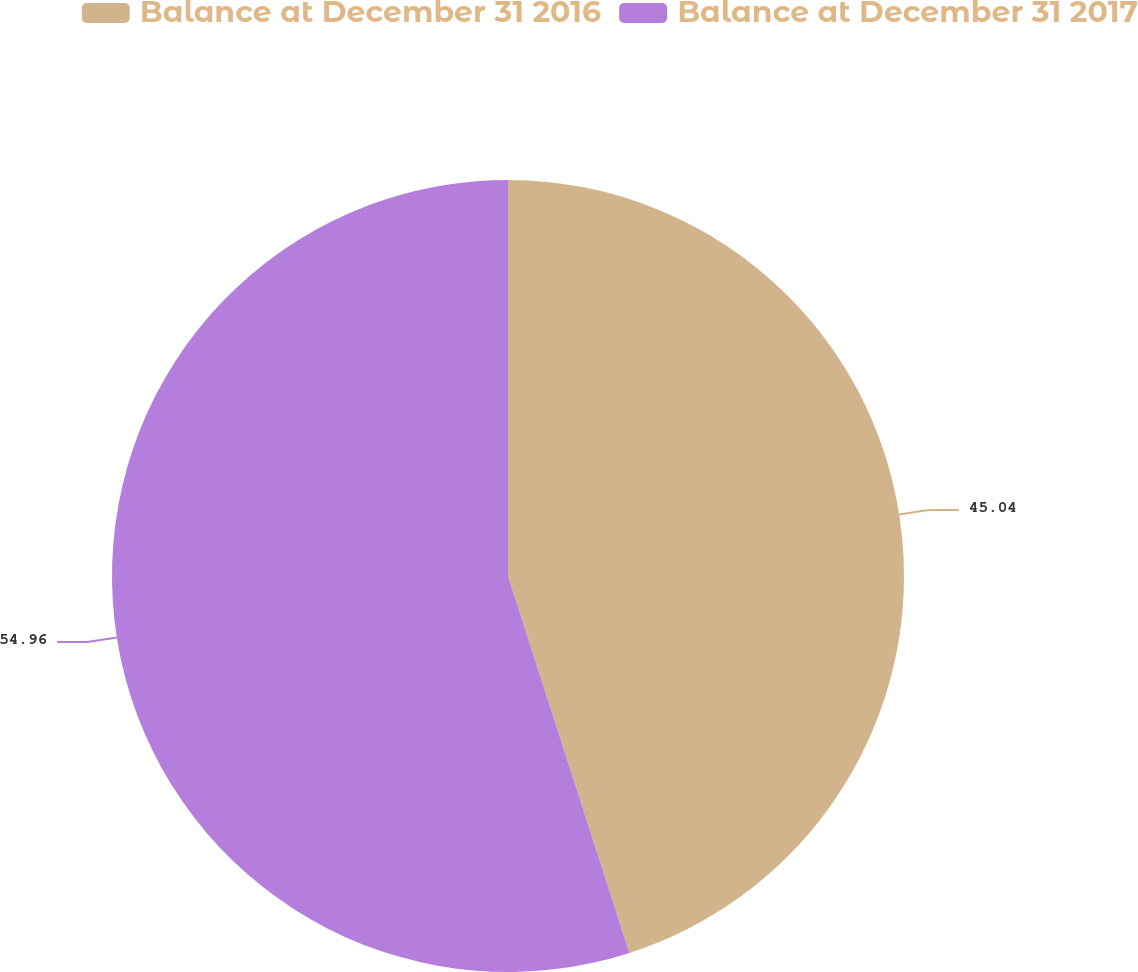Convert chart. <chart><loc_0><loc_0><loc_500><loc_500><pie_chart><fcel>Balance at December 31 2016<fcel>Balance at December 31 2017<nl><fcel>45.04%<fcel>54.96%<nl></chart> 